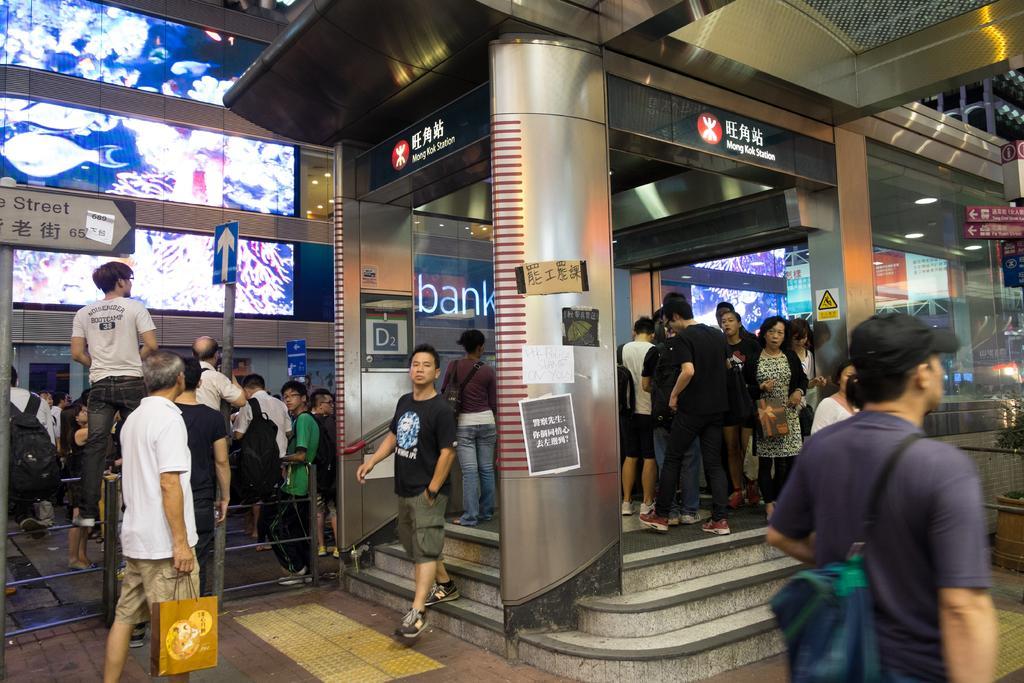In one or two sentences, can you explain what this image depicts? In this image there are group of people, and in the center there are some buildings and also i can see some poles and some boards. On the boards there is text, at the bottom there is a staircase and walkway and on the left side there is a railing. 